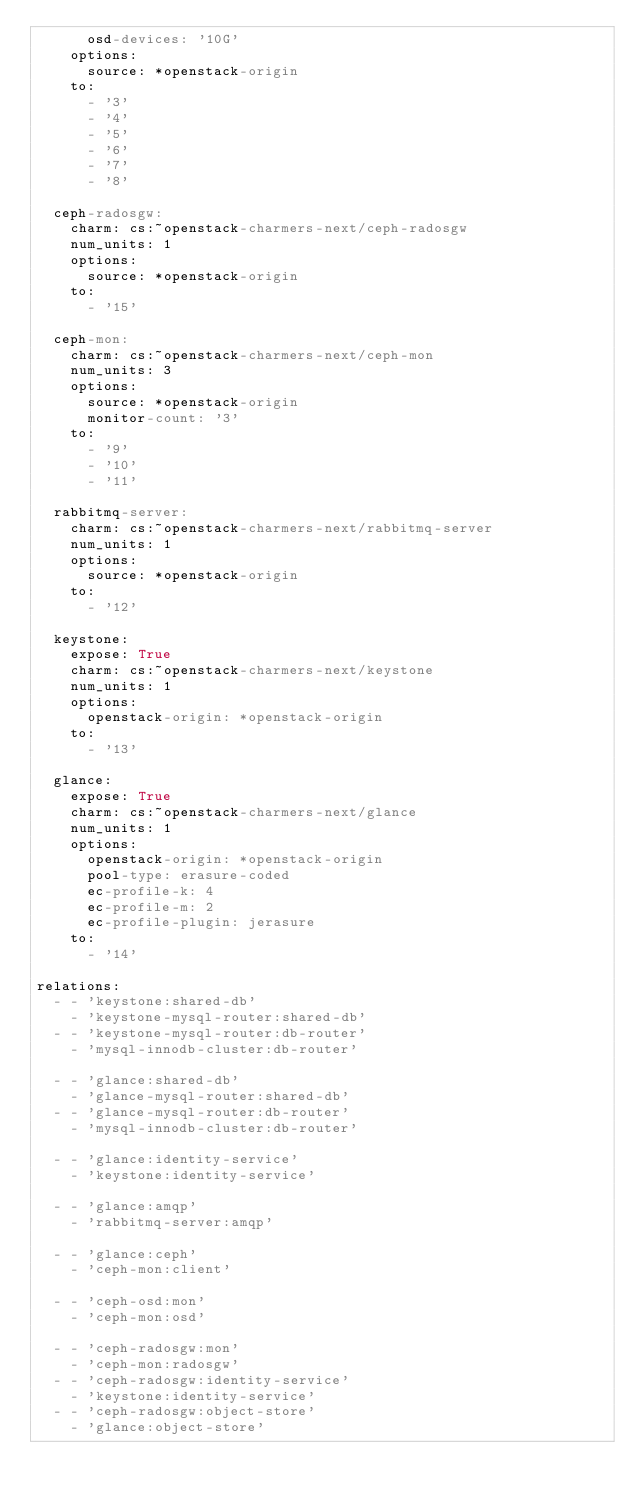<code> <loc_0><loc_0><loc_500><loc_500><_YAML_>      osd-devices: '10G'
    options:
      source: *openstack-origin
    to:
      - '3'
      - '4'
      - '5'
      - '6'
      - '7'
      - '8'

  ceph-radosgw:
    charm: cs:~openstack-charmers-next/ceph-radosgw
    num_units: 1
    options:
      source: *openstack-origin
    to:
      - '15'

  ceph-mon:
    charm: cs:~openstack-charmers-next/ceph-mon
    num_units: 3
    options:
      source: *openstack-origin
      monitor-count: '3'
    to:
      - '9'
      - '10'
      - '11'

  rabbitmq-server:
    charm: cs:~openstack-charmers-next/rabbitmq-server
    num_units: 1
    options:
      source: *openstack-origin
    to:
      - '12'

  keystone:
    expose: True
    charm: cs:~openstack-charmers-next/keystone
    num_units: 1
    options:
      openstack-origin: *openstack-origin
    to:
      - '13'

  glance:
    expose: True
    charm: cs:~openstack-charmers-next/glance
    num_units: 1
    options:
      openstack-origin: *openstack-origin
      pool-type: erasure-coded
      ec-profile-k: 4
      ec-profile-m: 2
      ec-profile-plugin: jerasure
    to:
      - '14'

relations:
  - - 'keystone:shared-db'
    - 'keystone-mysql-router:shared-db'
  - - 'keystone-mysql-router:db-router'
    - 'mysql-innodb-cluster:db-router'

  - - 'glance:shared-db'
    - 'glance-mysql-router:shared-db'
  - - 'glance-mysql-router:db-router'
    - 'mysql-innodb-cluster:db-router'

  - - 'glance:identity-service'
    - 'keystone:identity-service'

  - - 'glance:amqp'
    - 'rabbitmq-server:amqp'

  - - 'glance:ceph'
    - 'ceph-mon:client'

  - - 'ceph-osd:mon'
    - 'ceph-mon:osd'

  - - 'ceph-radosgw:mon'
    - 'ceph-mon:radosgw'
  - - 'ceph-radosgw:identity-service'
    - 'keystone:identity-service'
  - - 'ceph-radosgw:object-store'
    - 'glance:object-store'
</code> 